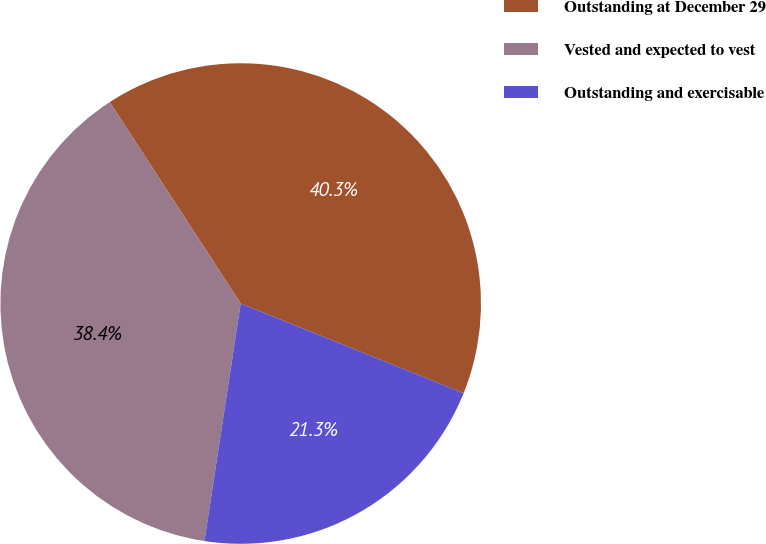Convert chart. <chart><loc_0><loc_0><loc_500><loc_500><pie_chart><fcel>Outstanding at December 29<fcel>Vested and expected to vest<fcel>Outstanding and exercisable<nl><fcel>40.26%<fcel>38.41%<fcel>21.32%<nl></chart> 